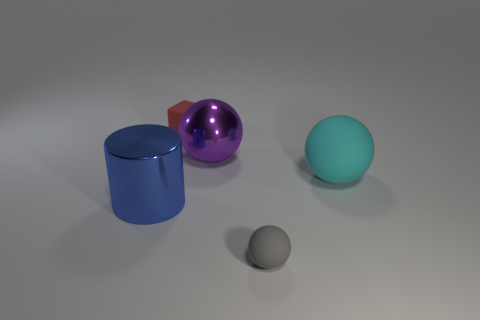How many objects are either rubber objects that are behind the large metal ball or small purple metallic blocks?
Ensure brevity in your answer.  1. How many other things are there of the same size as the red thing?
Provide a short and direct response. 1. There is a metal object that is on the left side of the tiny red matte thing; how big is it?
Your response must be concise. Large. There is a object that is made of the same material as the big blue cylinder; what shape is it?
Give a very brief answer. Sphere. Is there any other thing that is the same color as the tiny cube?
Offer a very short reply. No. What is the color of the big thing to the left of the small thing that is to the left of the small ball?
Ensure brevity in your answer.  Blue. What number of big things are either brown objects or blue cylinders?
Ensure brevity in your answer.  1. What material is the cyan thing that is the same shape as the tiny gray matte thing?
Your answer should be compact. Rubber. What color is the large cylinder?
Your answer should be compact. Blue. There is a matte thing that is on the left side of the big purple sphere; how many blue metallic cylinders are in front of it?
Ensure brevity in your answer.  1. 